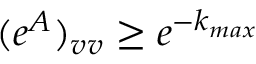<formula> <loc_0><loc_0><loc_500><loc_500>( e ^ { A } ) _ { v v } \geq e ^ { - k _ { \max } }</formula> 